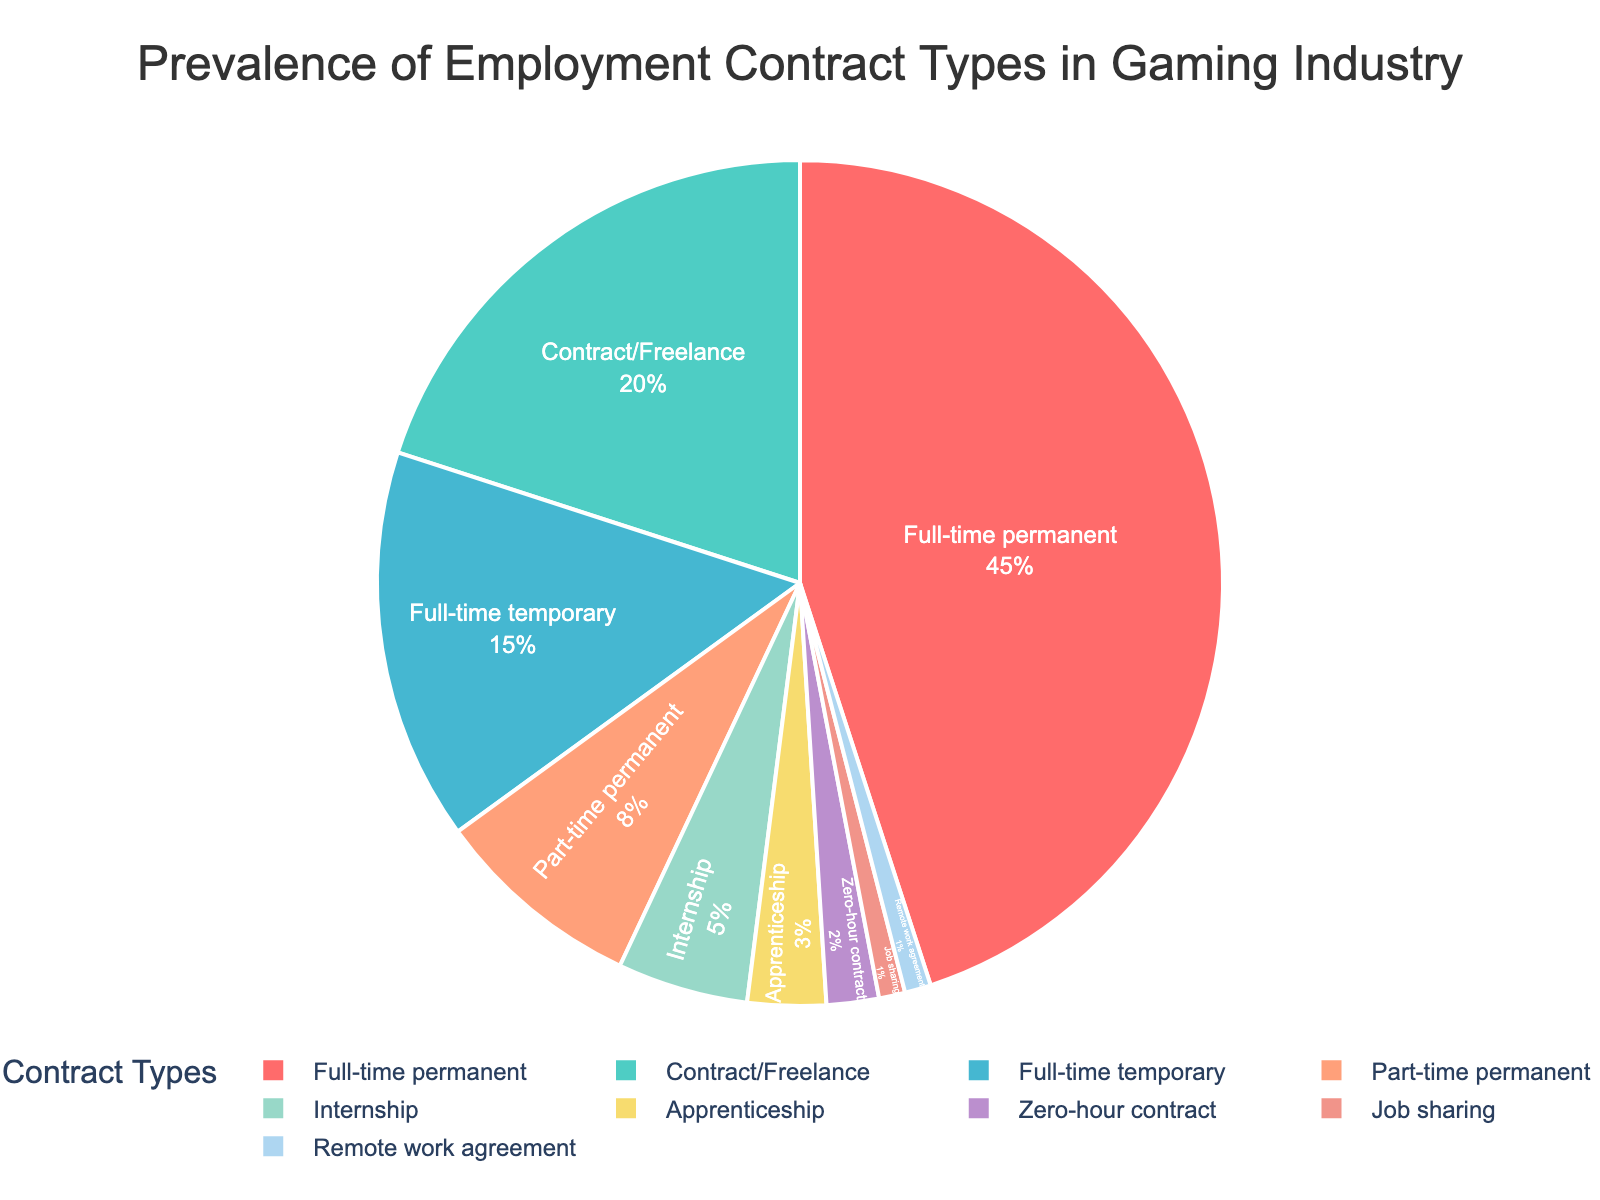Which type of contract is the most prevalent in the gaming industry? The pie chart shows that the "Full-time permanent" slice is the largest, indicating it's the most common contract.
Answer: Full-time permanent What percentage of gaming industry workers are on part-time permanent contracts? By referring to the pie chart, the "Part-time permanent" slice is labeled with its percentage.
Answer: 8% Which contract types together make up more than 50% of the gaming industry employment? Adding the percentages of the top contract types until the sum exceeds 50%. "Full-time permanent" (45%) and "Contract/Freelance" (20%) sum to 65%.
Answer: Full-time permanent, Contract/Freelance Are there more workers on internships or apprenticeship agreements? Comparing the sizes/percentages of the "Internship" and "Apprenticeship" slices directly on the pie chart.
Answer: Internships What is the total percentage of workers under temporary contracts (including full-time temporary, part-time permanent, and zero-hour contracts)? Summing the percentages for "Full-time temporary" (15%), "Part-time permanent" (8%), and "Zero-hour contract" (2%). 15% + 8% + 2% = 25%
Answer: 25% Which contract types each constitute less than 5% of the gamer workforce? Identifying slices with percentages less than 5% directly from the pie chart.
Answer: Internship, Apprenticeship, Zero-hour contract, Job sharing, Remote work agreement How many more people are on full-time permanent contracts compared to contract/freelance work? Subtracting the percentage of "Contract/Freelance" (20%) from "Full-time permanent" (45%). 45% - 20% = 25%
Answer: 25% What is the least common type of contract? Identifying the smallest slice on the pie chart.
Answer: Job sharing, Remote work agreement What proportion of the workforce is employed through flexible or non-traditional agreements (including contract/freelance, zero-hour contract, and remote work agreement)? Summing the relevant percentages: "Contract/Freelance" (20%), "Zero-hour contract" (2%), "Remote work agreement" (1%) totaling 20% + 2% + 1% = 23%
Answer: 23% Are internships more common than apprenticeships? Comparing the sizes/percentages of the "Internship" and "Apprenticeship" slices directly on the pie chart.
Answer: Yes 